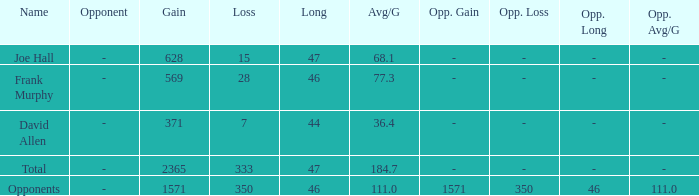How much Avg/G has a Gain smaller than 1571, and a Long smaller than 46? 1.0. 